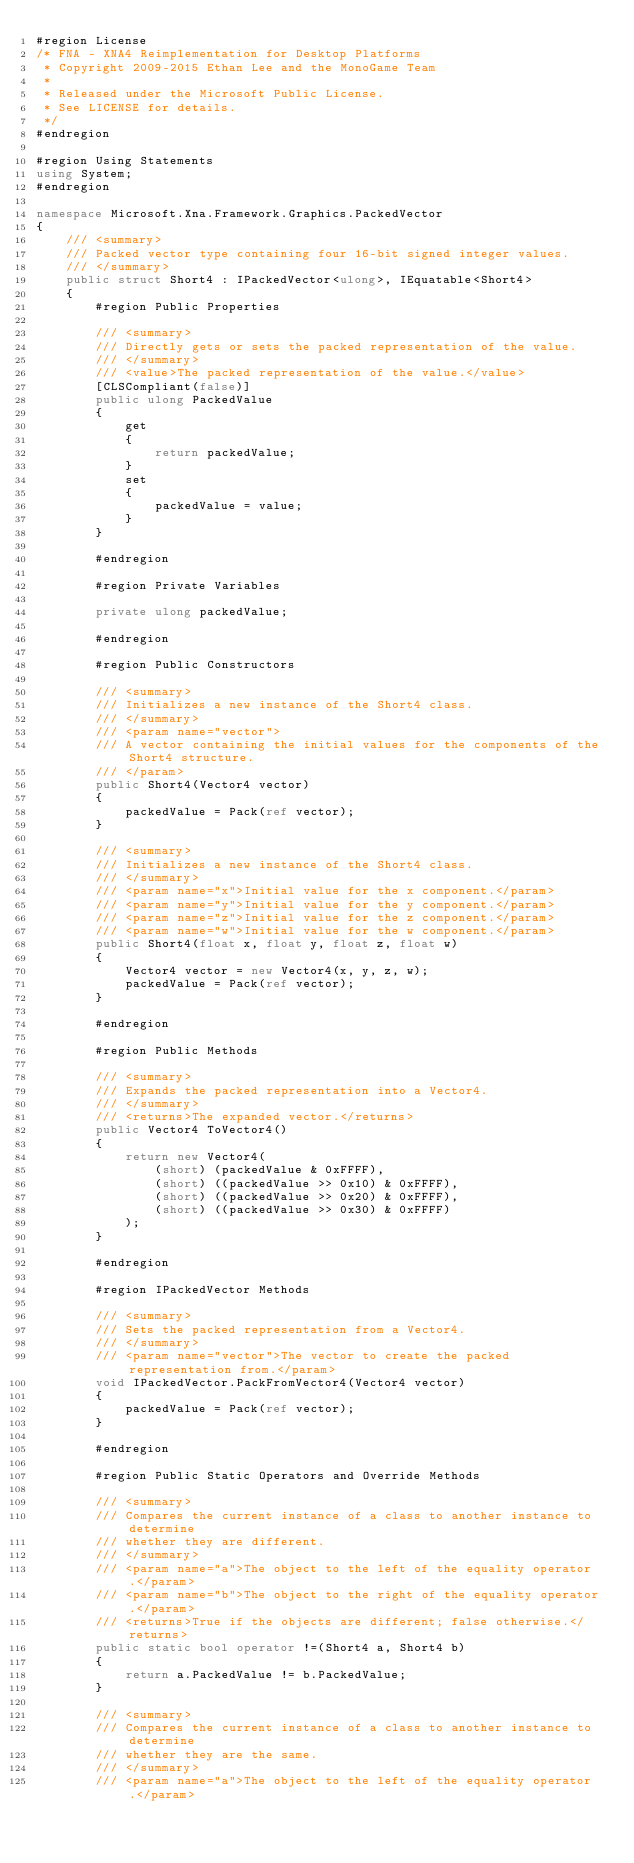<code> <loc_0><loc_0><loc_500><loc_500><_C#_>#region License
/* FNA - XNA4 Reimplementation for Desktop Platforms
 * Copyright 2009-2015 Ethan Lee and the MonoGame Team
 *
 * Released under the Microsoft Public License.
 * See LICENSE for details.
 */
#endregion

#region Using Statements
using System;
#endregion

namespace Microsoft.Xna.Framework.Graphics.PackedVector
{
	/// <summary>
	/// Packed vector type containing four 16-bit signed integer values.
	/// </summary>
	public struct Short4 : IPackedVector<ulong>, IEquatable<Short4>
	{
		#region Public Properties

		/// <summary>
		/// Directly gets or sets the packed representation of the value.
		/// </summary>
		/// <value>The packed representation of the value.</value>
		[CLSCompliant(false)]
		public ulong PackedValue
		{
			get
			{
				return packedValue;
			}
			set
			{
				packedValue = value;
			}
		}

		#endregion

		#region Private Variables

		private ulong packedValue;

		#endregion

		#region Public Constructors

		/// <summary>
		/// Initializes a new instance of the Short4 class.
		/// </summary>
		/// <param name="vector">
		/// A vector containing the initial values for the components of the Short4 structure.
		/// </param>
		public Short4(Vector4 vector)
		{
			packedValue = Pack(ref vector);
		}

		/// <summary>
		/// Initializes a new instance of the Short4 class.
		/// </summary>
		/// <param name="x">Initial value for the x component.</param>
		/// <param name="y">Initial value for the y component.</param>
		/// <param name="z">Initial value for the z component.</param>
		/// <param name="w">Initial value for the w component.</param>
		public Short4(float x, float y, float z, float w)
		{
			Vector4 vector = new Vector4(x, y, z, w);
			packedValue = Pack(ref vector);
		}

		#endregion

		#region Public Methods

		/// <summary>
		/// Expands the packed representation into a Vector4.
		/// </summary>
		/// <returns>The expanded vector.</returns>
		public Vector4 ToVector4()
		{
			return new Vector4(
				(short) (packedValue & 0xFFFF),
				(short) ((packedValue >> 0x10) & 0xFFFF),
				(short) ((packedValue >> 0x20) & 0xFFFF),
				(short) ((packedValue >> 0x30) & 0xFFFF)
			);
		}

		#endregion

		#region IPackedVector Methods

		/// <summary>
		/// Sets the packed representation from a Vector4.
		/// </summary>
		/// <param name="vector">The vector to create the packed representation from.</param>
		void IPackedVector.PackFromVector4(Vector4 vector)
		{
			packedValue = Pack(ref vector);
		}

		#endregion

		#region Public Static Operators and Override Methods

		/// <summary>
		/// Compares the current instance of a class to another instance to determine
		/// whether they are different.
		/// </summary>
		/// <param name="a">The object to the left of the equality operator.</param>
		/// <param name="b">The object to the right of the equality operator.</param>
		/// <returns>True if the objects are different; false otherwise.</returns>
		public static bool operator !=(Short4 a, Short4 b)
		{
			return a.PackedValue != b.PackedValue;
		}

		/// <summary>
		/// Compares the current instance of a class to another instance to determine
		/// whether they are the same.
		/// </summary>
		/// <param name="a">The object to the left of the equality operator.</param></code> 